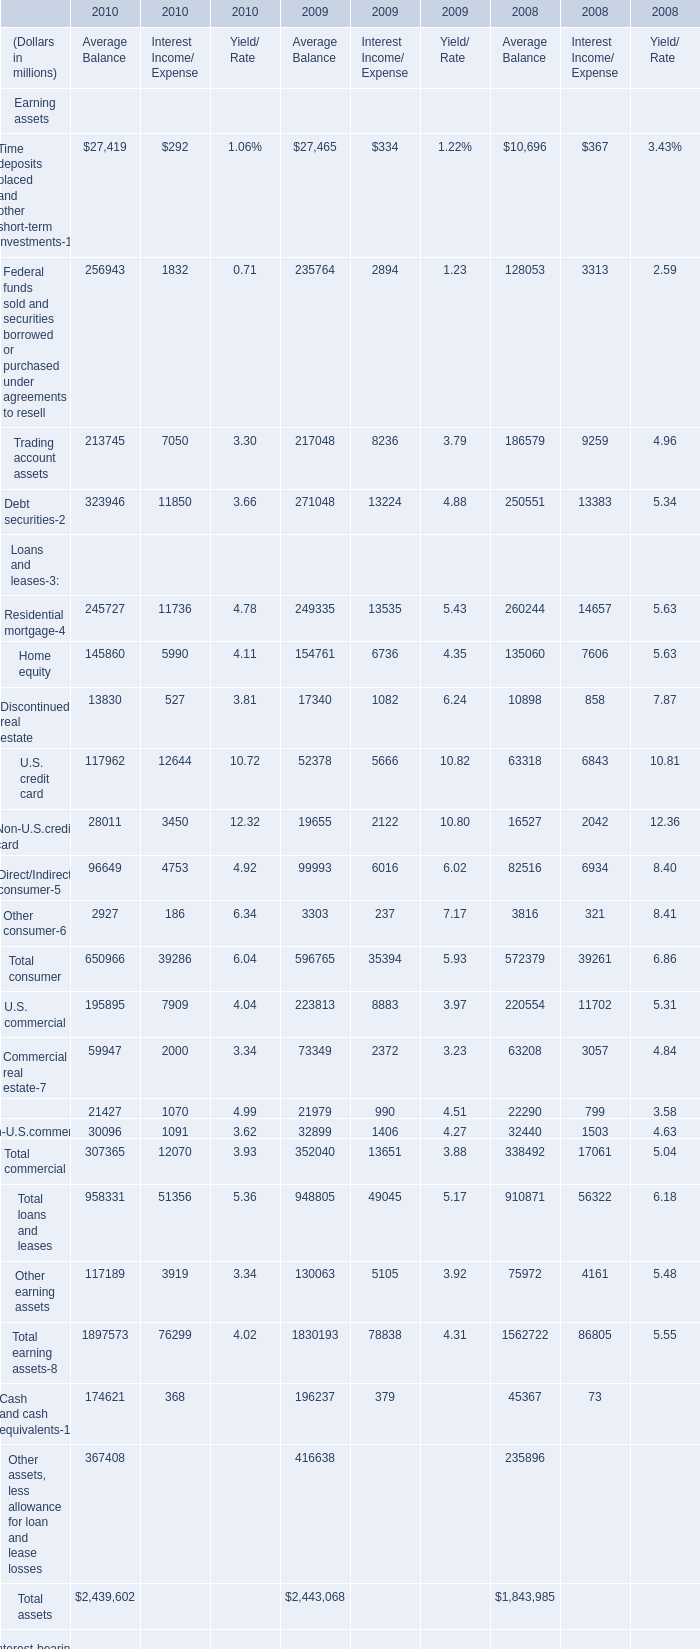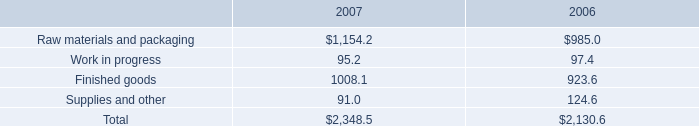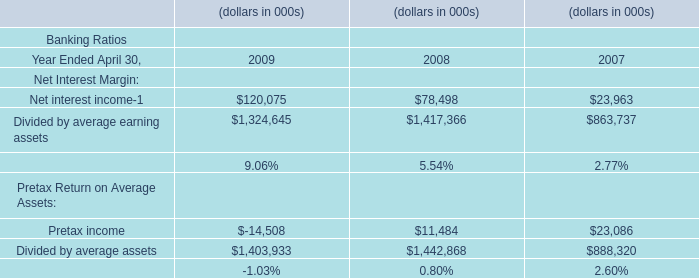What is the sum of Direct/Indirect consumer of 2009 Average Balance, and Raw materials and packaging of 2007 ? 
Computations: (99993.0 + 1154.2)
Answer: 101147.2. 